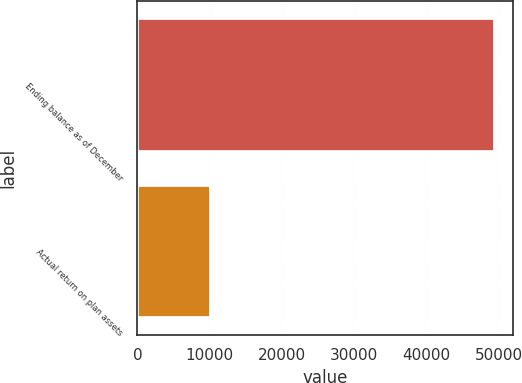Convert chart. <chart><loc_0><loc_0><loc_500><loc_500><bar_chart><fcel>Ending balance as of December<fcel>Actual return on plan assets<nl><fcel>49556<fcel>10249<nl></chart> 